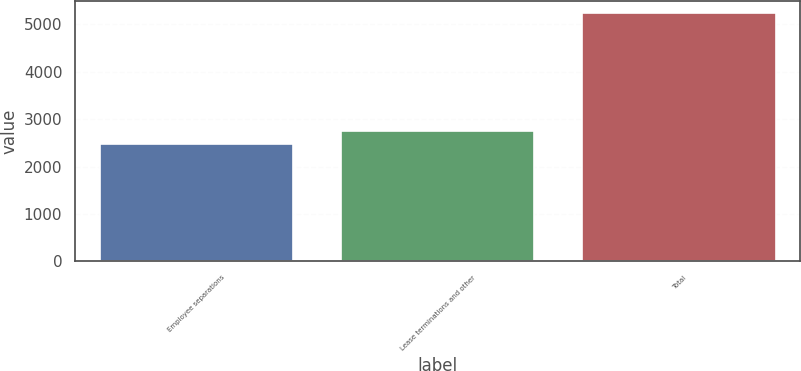Convert chart. <chart><loc_0><loc_0><loc_500><loc_500><bar_chart><fcel>Employee separations<fcel>Lease terminations and other<fcel>Total<nl><fcel>2482<fcel>2757.4<fcel>5236<nl></chart> 